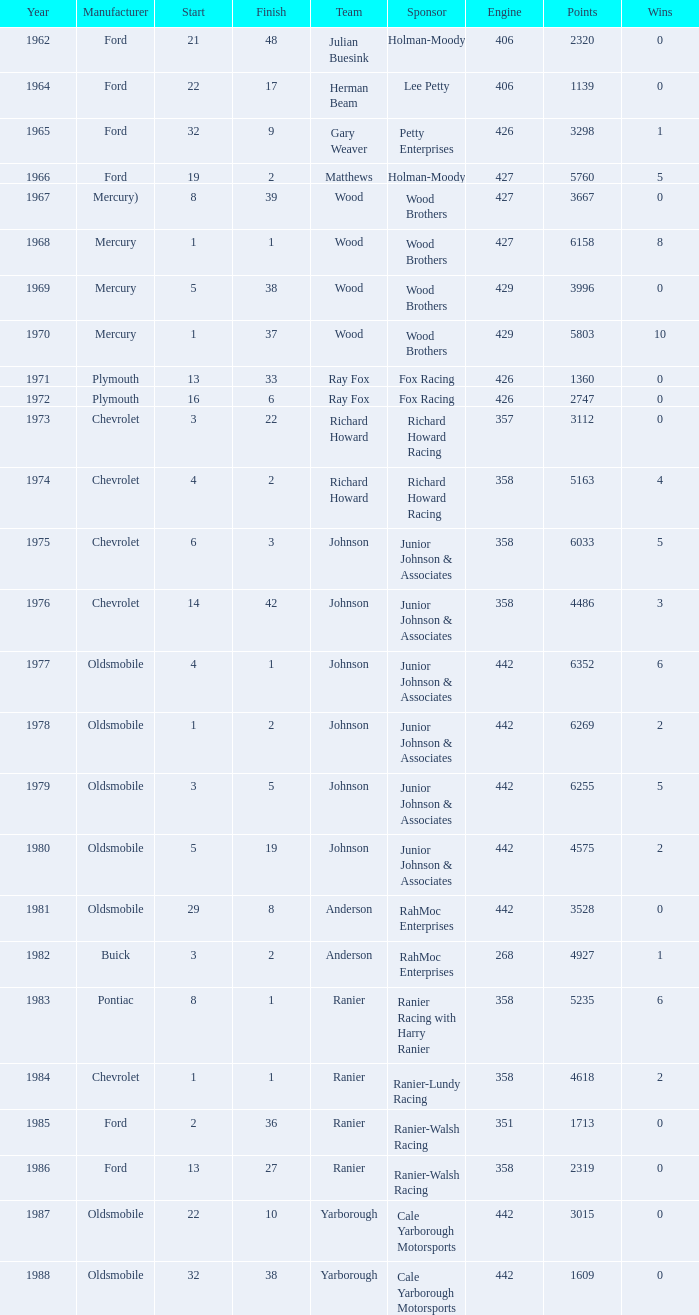Who was the maufacturer of the vehicle during the race where Cale Yarborough started at 19 and finished earlier than 42? Ford. 